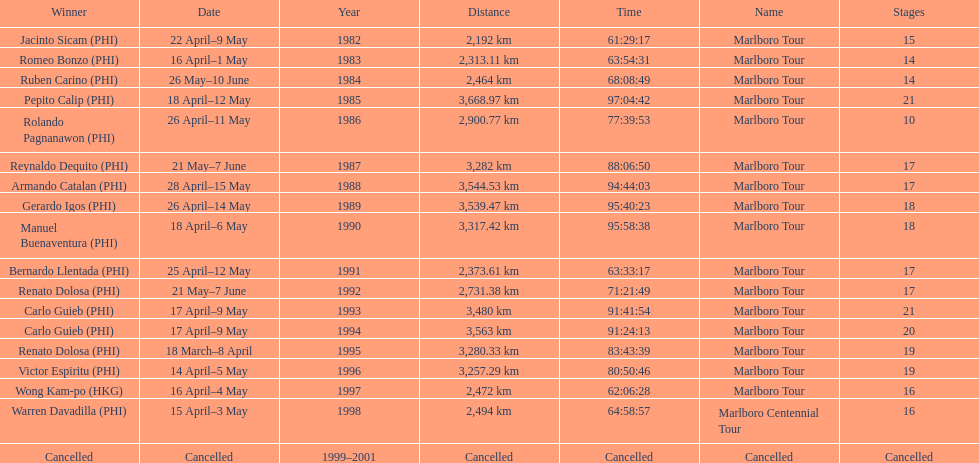Before the tour got canceled, what was the overall count of winners? 17. 